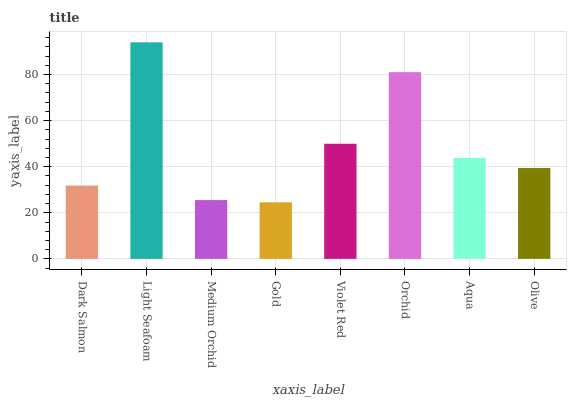Is Gold the minimum?
Answer yes or no. Yes. Is Light Seafoam the maximum?
Answer yes or no. Yes. Is Medium Orchid the minimum?
Answer yes or no. No. Is Medium Orchid the maximum?
Answer yes or no. No. Is Light Seafoam greater than Medium Orchid?
Answer yes or no. Yes. Is Medium Orchid less than Light Seafoam?
Answer yes or no. Yes. Is Medium Orchid greater than Light Seafoam?
Answer yes or no. No. Is Light Seafoam less than Medium Orchid?
Answer yes or no. No. Is Aqua the high median?
Answer yes or no. Yes. Is Olive the low median?
Answer yes or no. Yes. Is Gold the high median?
Answer yes or no. No. Is Medium Orchid the low median?
Answer yes or no. No. 